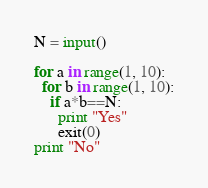Convert code to text. <code><loc_0><loc_0><loc_500><loc_500><_Python_>N = input()

for a in range(1, 10):
  for b in range(1, 10):
    if a*b==N:
      print "Yes"
      exit(0)
print "No"
</code> 